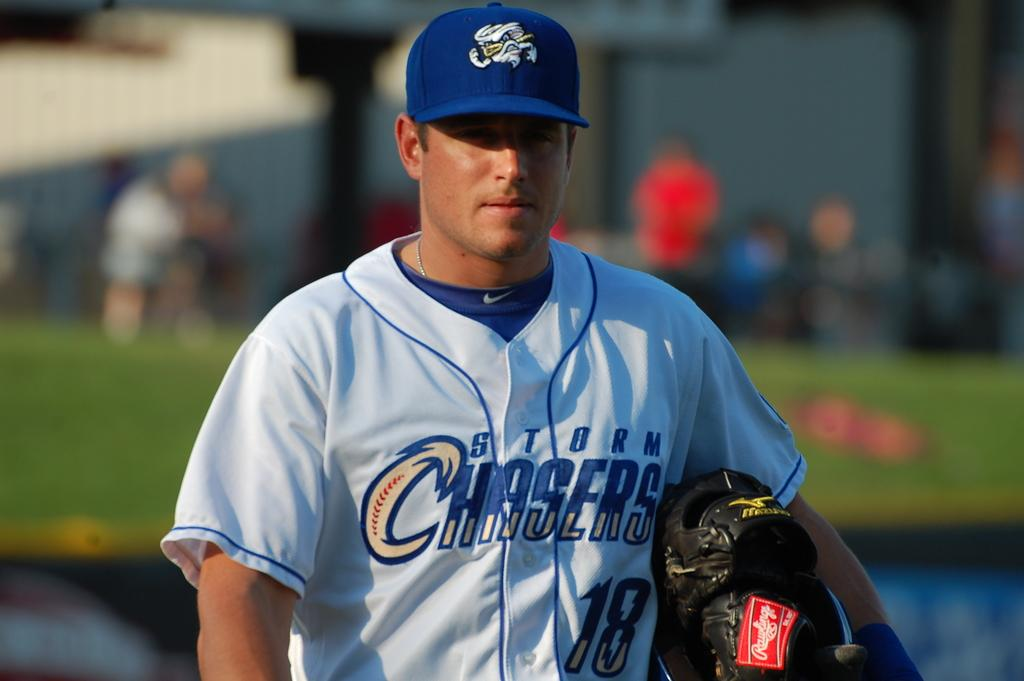<image>
Present a compact description of the photo's key features. A player wearing a white shirt with the words Storm Chasers on it 